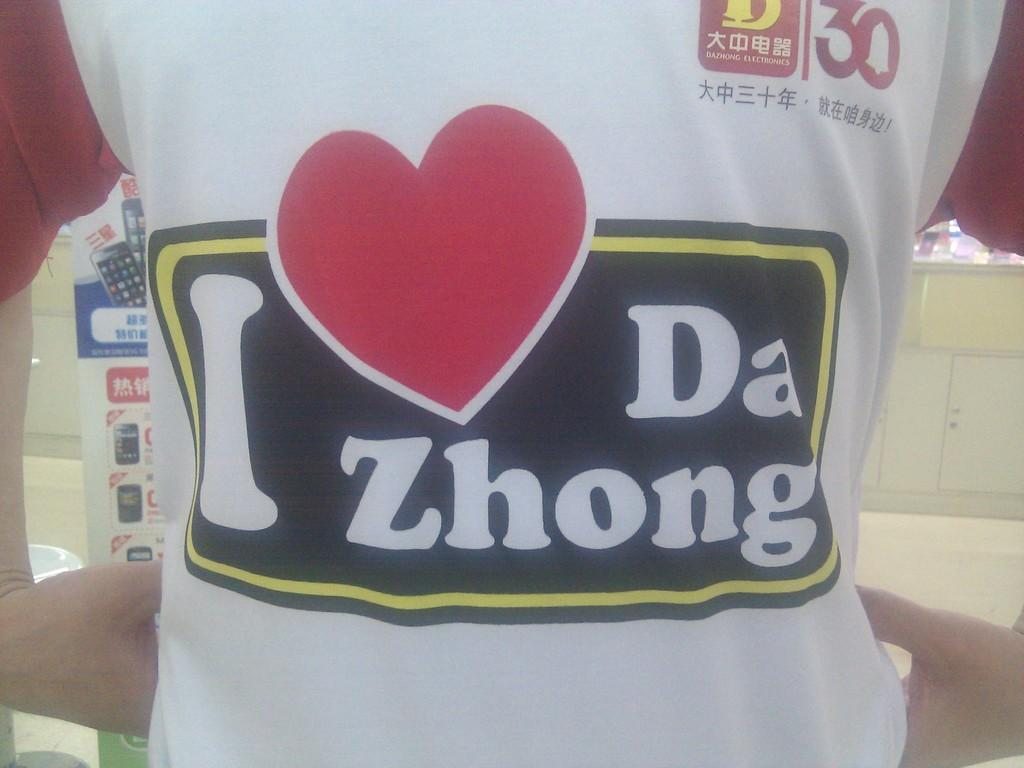<image>
Describe the image concisely. A white T shirt with I heart Da Zhong in a back box. 